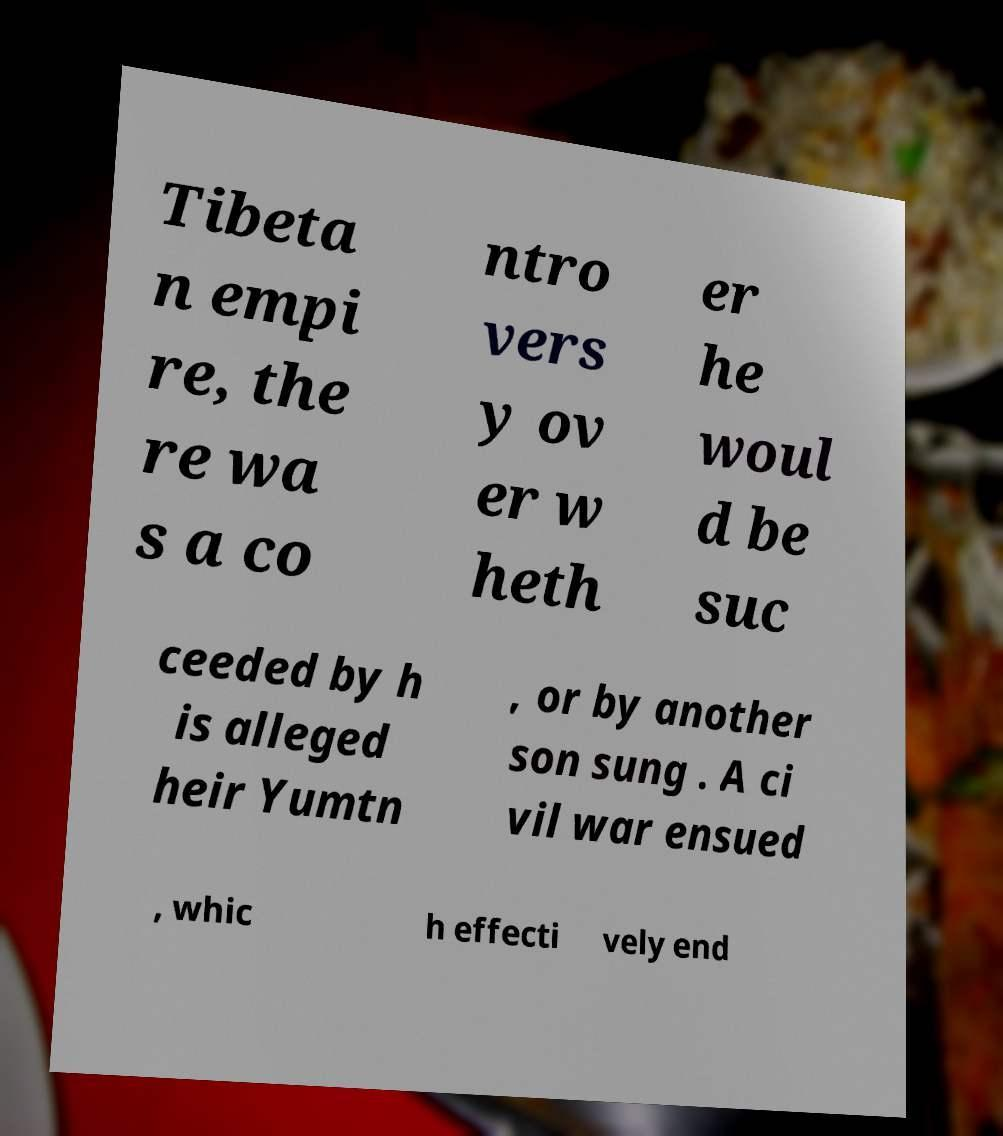For documentation purposes, I need the text within this image transcribed. Could you provide that? Tibeta n empi re, the re wa s a co ntro vers y ov er w heth er he woul d be suc ceeded by h is alleged heir Yumtn , or by another son sung . A ci vil war ensued , whic h effecti vely end 